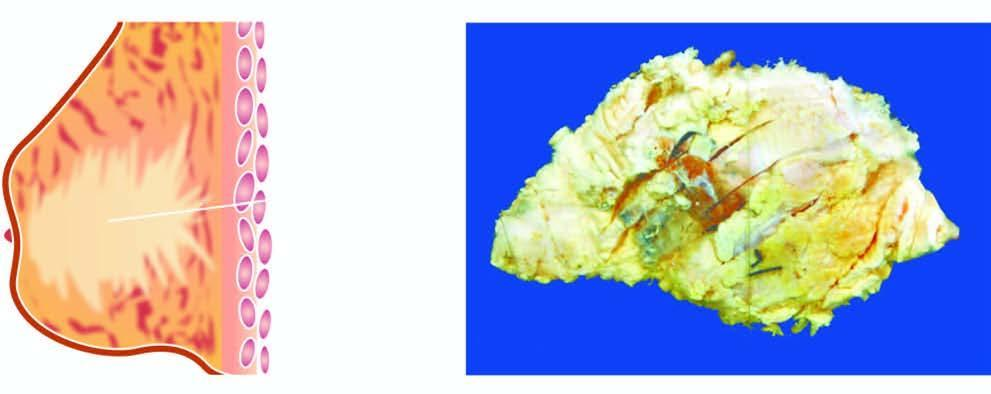does the inner circle shown with green line show a grey white firm tumour extending irregularly into adjacent breast parenchyma?
Answer the question using a single word or phrase. No 